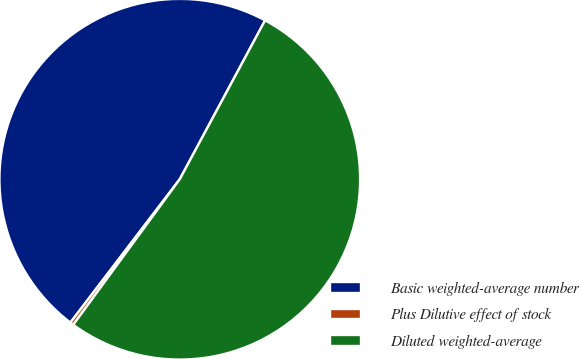Convert chart to OTSL. <chart><loc_0><loc_0><loc_500><loc_500><pie_chart><fcel>Basic weighted-average number<fcel>Plus Dilutive effect of stock<fcel>Diluted weighted-average<nl><fcel>47.47%<fcel>0.32%<fcel>52.21%<nl></chart> 